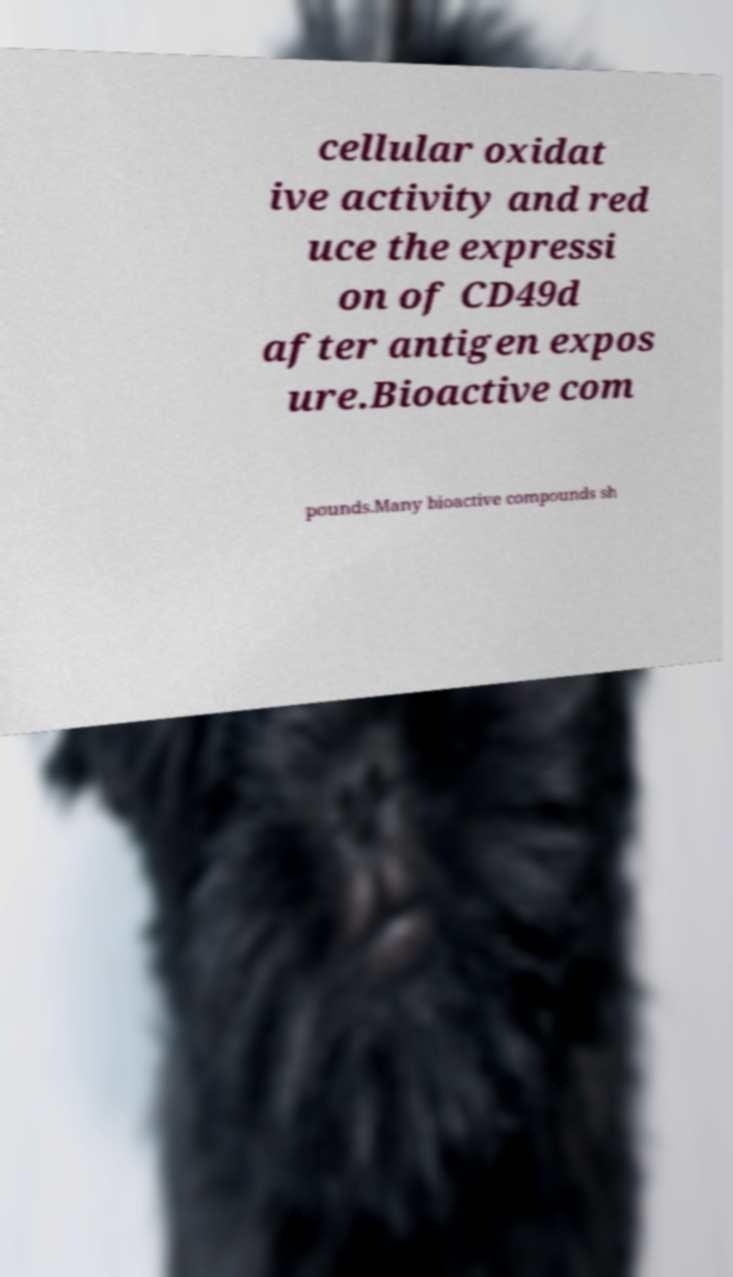There's text embedded in this image that I need extracted. Can you transcribe it verbatim? cellular oxidat ive activity and red uce the expressi on of CD49d after antigen expos ure.Bioactive com pounds.Many bioactive compounds sh 